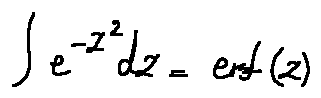Convert formula to latex. <formula><loc_0><loc_0><loc_500><loc_500>\int e ^ { - z ^ { 2 } } d z = e r f ( z )</formula> 